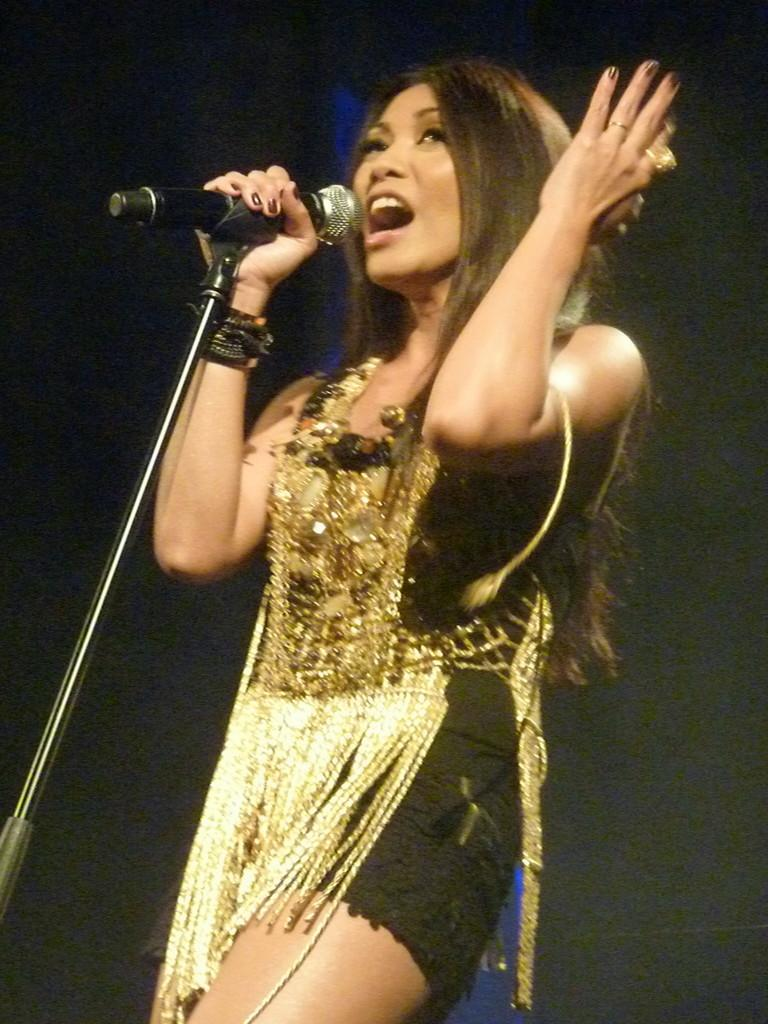Who is the main subject in the image? There is a woman in the image. What is the woman doing in the image? The woman is standing and singing. What is she wearing in the image? She is wearing a black and golden color dress. What object is she holding in the image? She is holding a mic. What other object related to singing can be seen in the image? There is a mic stand in the image. How would you describe the background of the image? The background is dark. What is the woman's sister doing in the image? There is no mention of a sister in the image, so we cannot answer this question. --- 